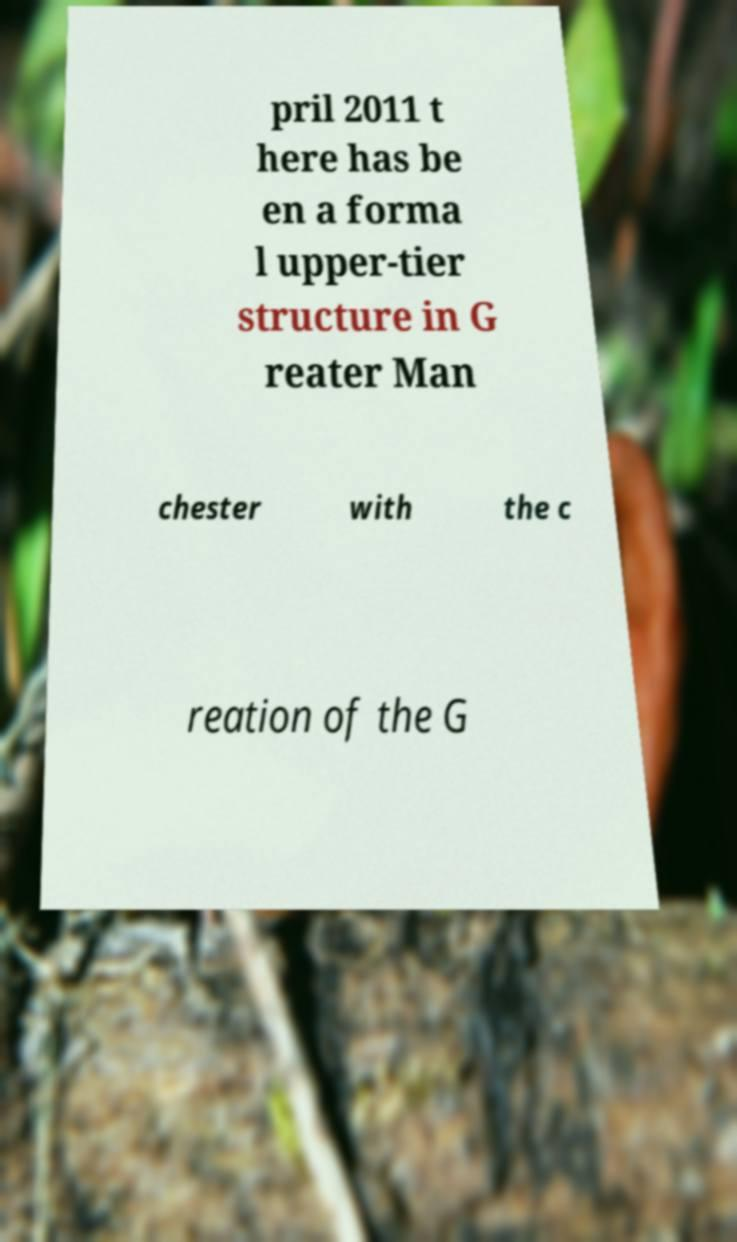What messages or text are displayed in this image? I need them in a readable, typed format. pril 2011 t here has be en a forma l upper-tier structure in G reater Man chester with the c reation of the G 